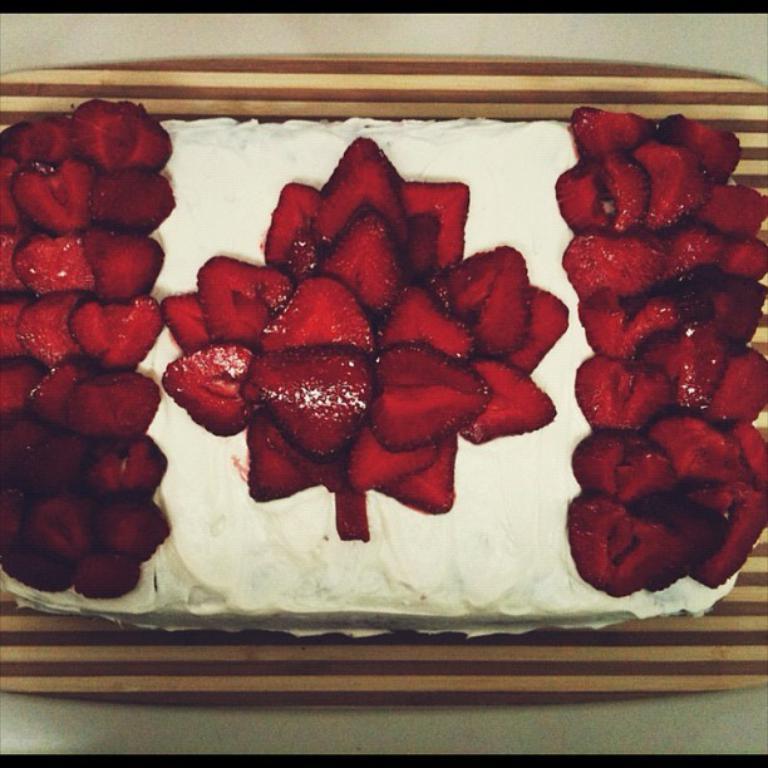Can you describe this image briefly? Here we can see a cake garnished with strawberries which is on a platform. 